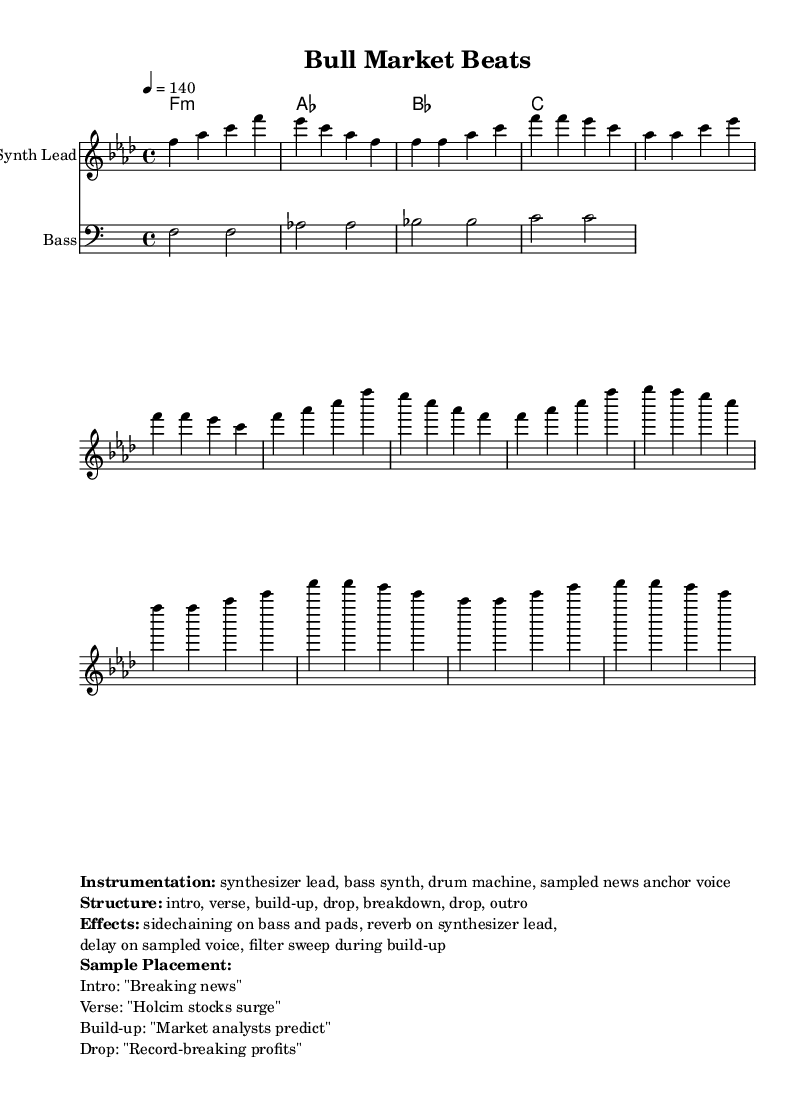What is the key signature of this music? The key signature indicates the tonal center, which is F minor in this case, as shown by the presence of four flats in the key signature section.
Answer: F minor What is the time signature of this music? The time signature is located at the beginning of the music sheet and is indicated as 4/4, meaning there are four beats in each measure and the quarter note receives one beat.
Answer: 4/4 What is the tempo of this music? The tempo is indicated at the beginning with a note value and beats per minute, specifically 140 beats per minute, suggesting a fast-paced energy suitable for dance music.
Answer: 140 How many main sections are in the structure of this piece? By examining the structured notation and the markup section, we can see the piece is divided into six distinct sections: intro, verse, build-up, drop, breakdown, and outro, leading to a total count of six.
Answer: 6 What type of synthesizer is primarily mentioned in the instrumentation? The music sheet mentions "synthesizer lead" as the key instrument in the instrumentation section, indicating its importance in the overall sound of the piece.
Answer: synthesizer lead During which section does the sampled news anchor voice first appear? The markup specifies that the sampled news anchor voice is introduced during the "Intro" section of the structure, indicating its placement within the composition.
Answer: Intro What musical effects are utilized on the bass and synthesizer lead? The markup outlines that "sidechaining on bass and pads" and "reverb on synthesizer lead" are the primary effects applied, enhancing the sound dynamic and creating a lively atmosphere fitting for dance music.
Answer: sidechaining, reverb 